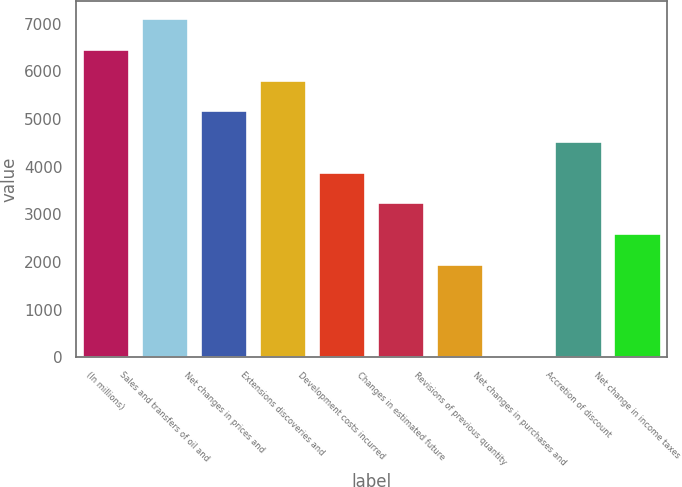<chart> <loc_0><loc_0><loc_500><loc_500><bar_chart><fcel>(In millions)<fcel>Sales and transfers of oil and<fcel>Net changes in prices and<fcel>Extensions discoveries and<fcel>Development costs incurred<fcel>Changes in estimated future<fcel>Revisions of previous quantity<fcel>Net changes in purchases and<fcel>Accretion of discount<fcel>Net change in income taxes<nl><fcel>6469<fcel>7112.6<fcel>5181.8<fcel>5825.4<fcel>3894.6<fcel>3251<fcel>1963.8<fcel>33<fcel>4538.2<fcel>2607.4<nl></chart> 